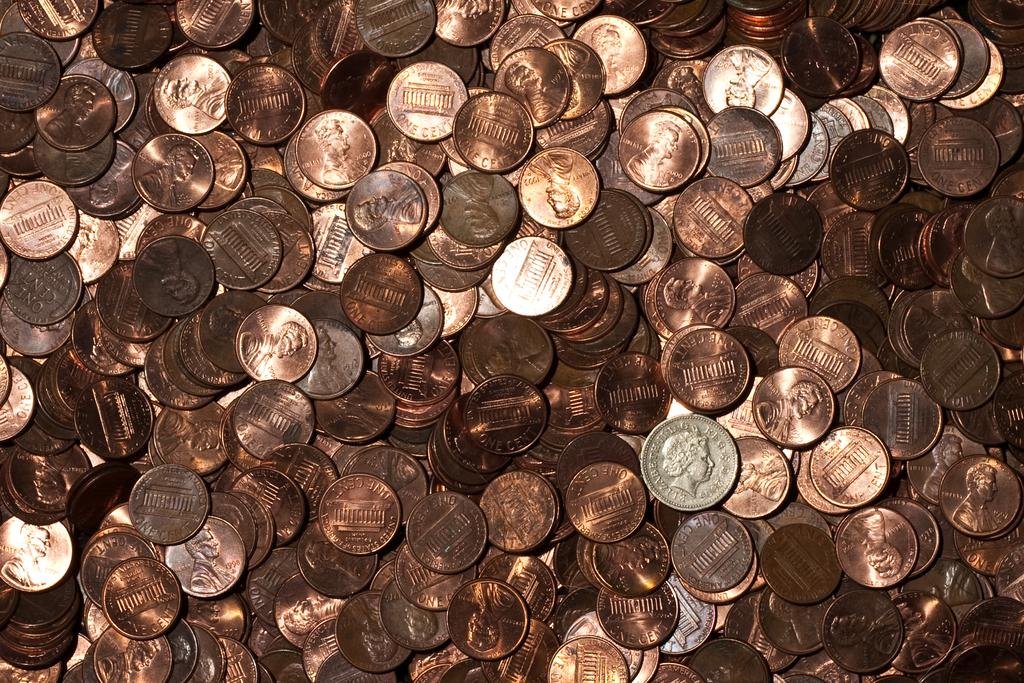What is the main subject of the image? The main subject of the image is a cluster of coins. Can you describe the colors of the coins? The coins are copper, silver, and bronze in color. What type of grape is hanging from the lamp in the image? There is no lamp or grape present in the image; it only features a cluster of coins. 